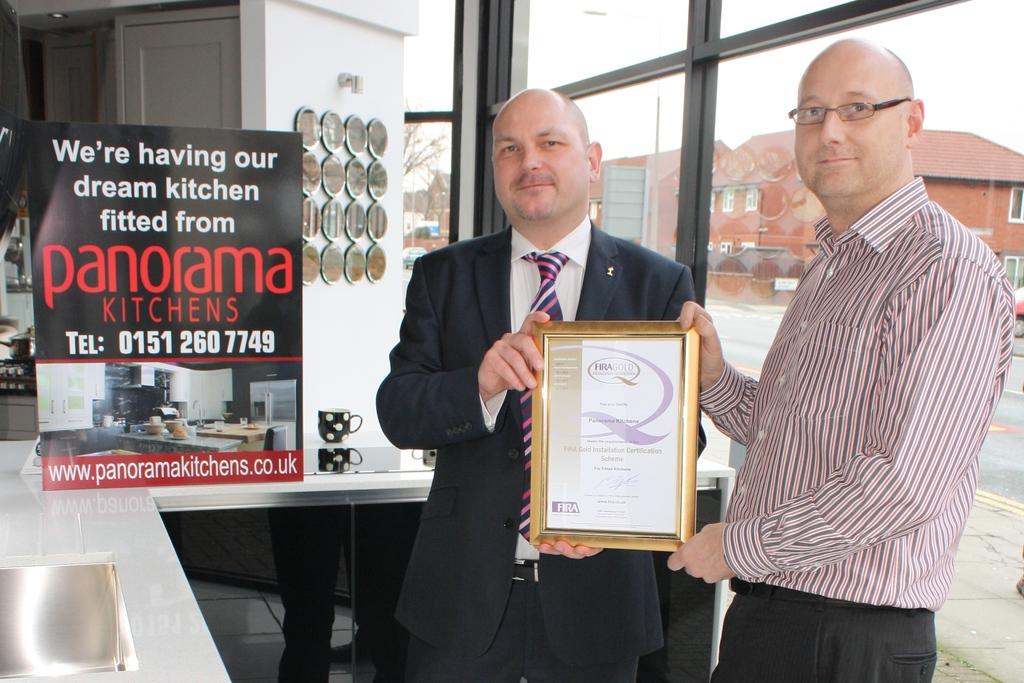What is the name of the company?
Offer a very short reply. Panorama kitchens. What is panorama kitchens telephone number?
Give a very brief answer. 0151 260 7749. 